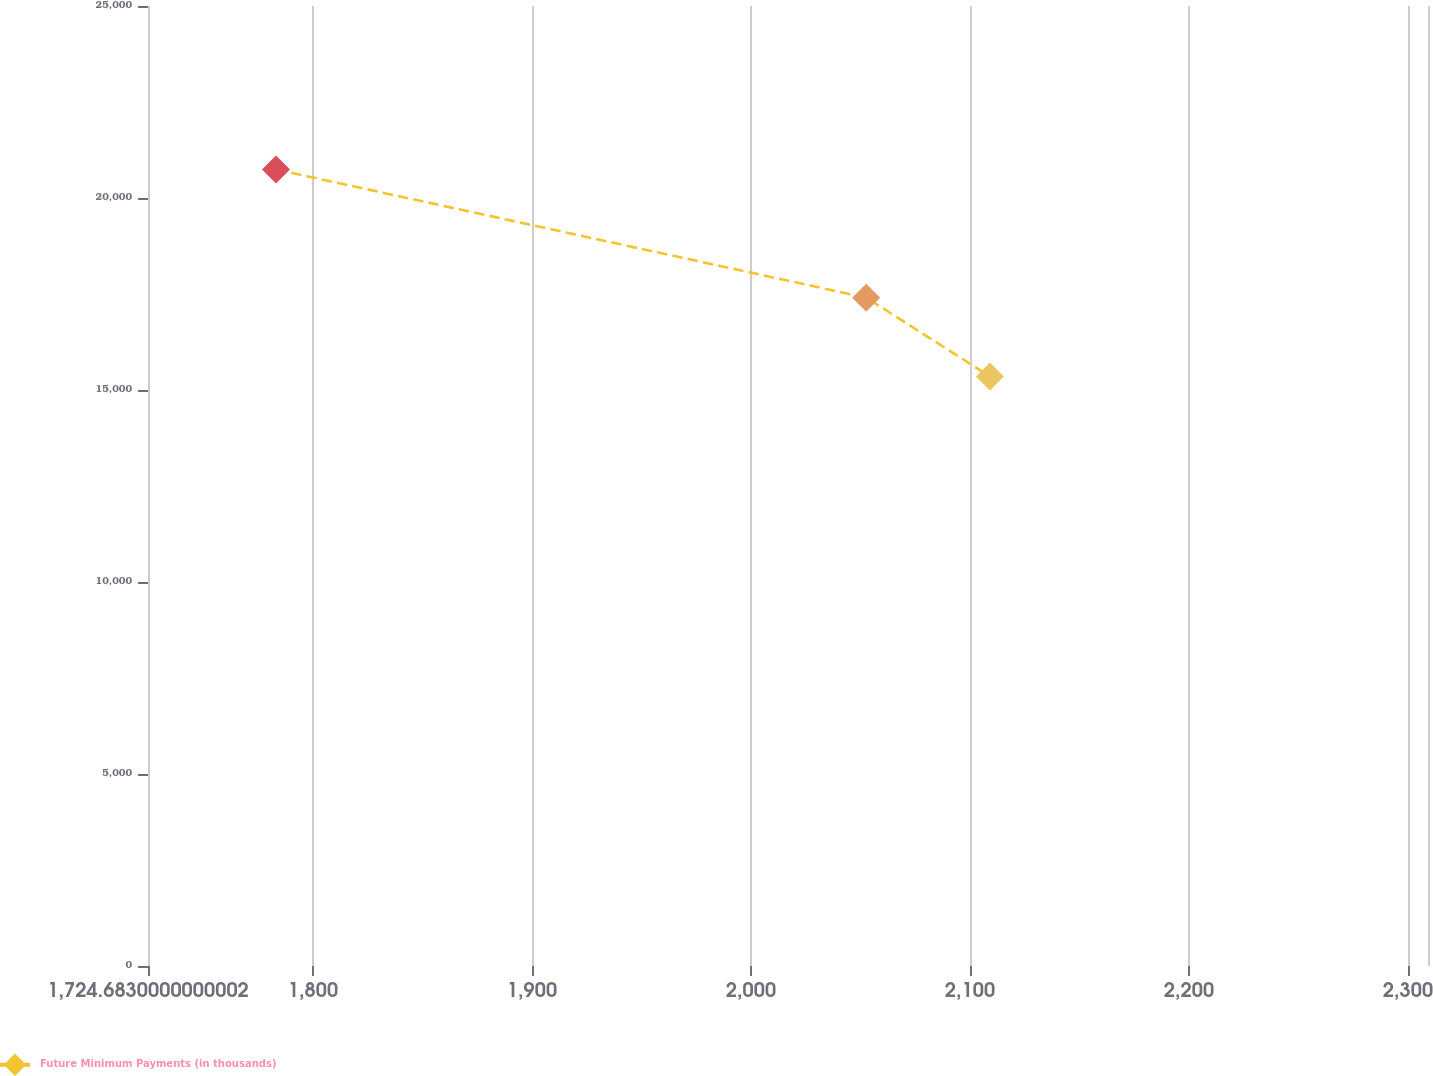<chart> <loc_0><loc_0><loc_500><loc_500><line_chart><ecel><fcel>Future Minimum Payments (in thousands)<nl><fcel>1783.13<fcel>20741.5<nl><fcel>2052.63<fcel>17404.5<nl><fcel>2109.12<fcel>15354.1<nl><fcel>2311.11<fcel>11103.2<nl><fcel>2367.6<fcel>9929.47<nl></chart> 